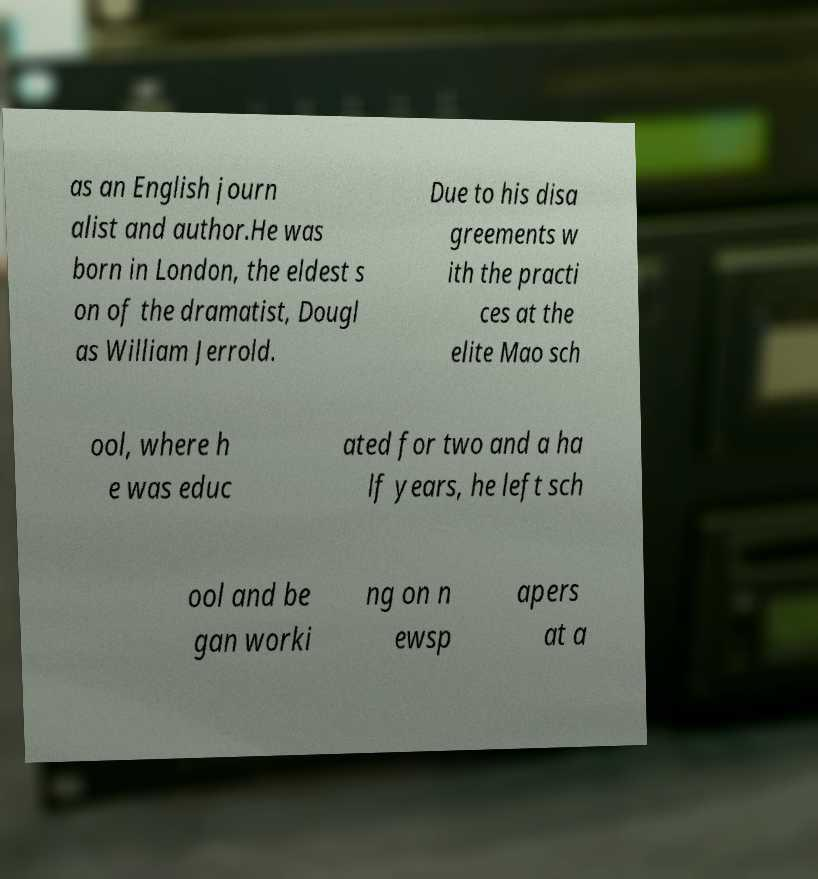Can you accurately transcribe the text from the provided image for me? as an English journ alist and author.He was born in London, the eldest s on of the dramatist, Dougl as William Jerrold. Due to his disa greements w ith the practi ces at the elite Mao sch ool, where h e was educ ated for two and a ha lf years, he left sch ool and be gan worki ng on n ewsp apers at a 